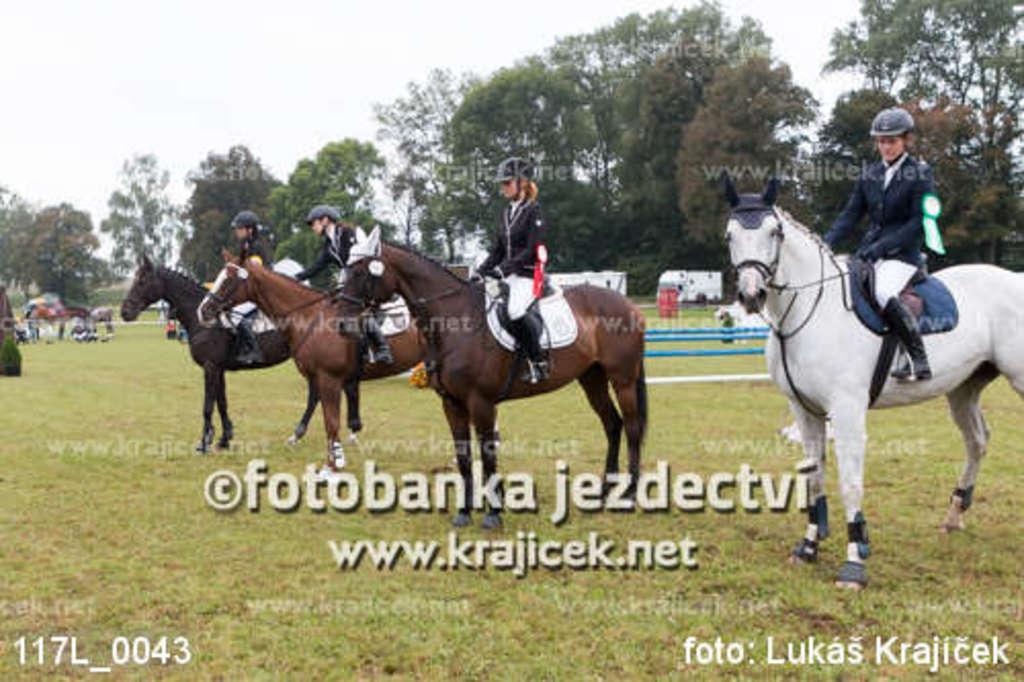Please provide a concise description of this image. In this image there are four persons sitting on the horses , and in the background there are group of people, trees, sky and watermarks on the image. 